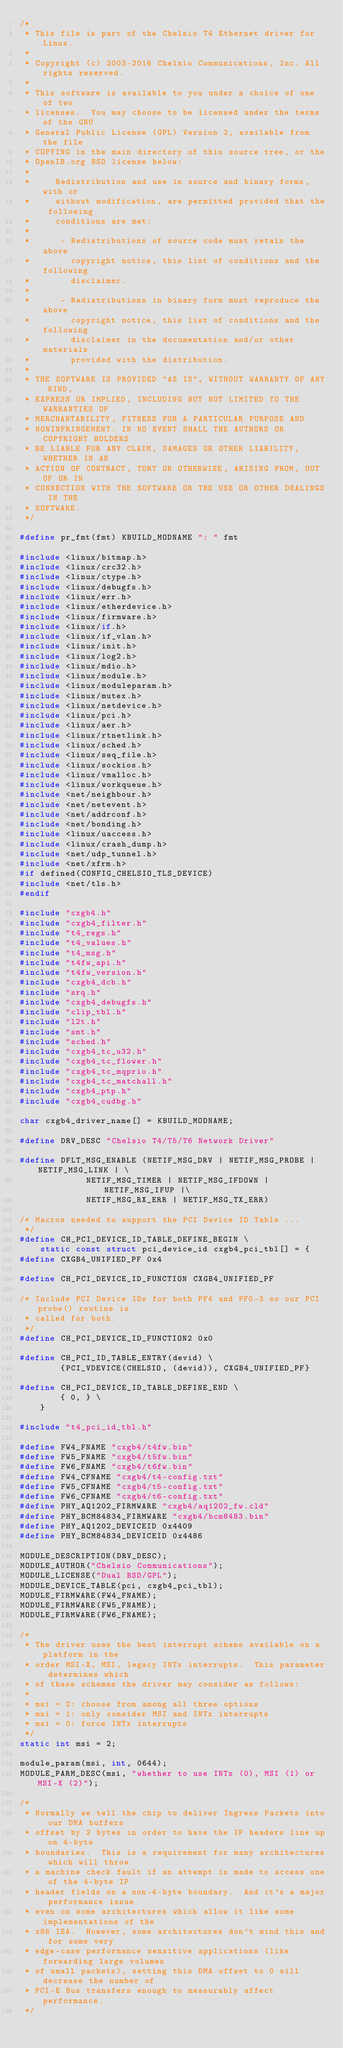Convert code to text. <code><loc_0><loc_0><loc_500><loc_500><_C_>/*
 * This file is part of the Chelsio T4 Ethernet driver for Linux.
 *
 * Copyright (c) 2003-2016 Chelsio Communications, Inc. All rights reserved.
 *
 * This software is available to you under a choice of one of two
 * licenses.  You may choose to be licensed under the terms of the GNU
 * General Public License (GPL) Version 2, available from the file
 * COPYING in the main directory of this source tree, or the
 * OpenIB.org BSD license below:
 *
 *     Redistribution and use in source and binary forms, with or
 *     without modification, are permitted provided that the following
 *     conditions are met:
 *
 *      - Redistributions of source code must retain the above
 *        copyright notice, this list of conditions and the following
 *        disclaimer.
 *
 *      - Redistributions in binary form must reproduce the above
 *        copyright notice, this list of conditions and the following
 *        disclaimer in the documentation and/or other materials
 *        provided with the distribution.
 *
 * THE SOFTWARE IS PROVIDED "AS IS", WITHOUT WARRANTY OF ANY KIND,
 * EXPRESS OR IMPLIED, INCLUDING BUT NOT LIMITED TO THE WARRANTIES OF
 * MERCHANTABILITY, FITNESS FOR A PARTICULAR PURPOSE AND
 * NONINFRINGEMENT. IN NO EVENT SHALL THE AUTHORS OR COPYRIGHT HOLDERS
 * BE LIABLE FOR ANY CLAIM, DAMAGES OR OTHER LIABILITY, WHETHER IN AN
 * ACTION OF CONTRACT, TORT OR OTHERWISE, ARISING FROM, OUT OF OR IN
 * CONNECTION WITH THE SOFTWARE OR THE USE OR OTHER DEALINGS IN THE
 * SOFTWARE.
 */

#define pr_fmt(fmt) KBUILD_MODNAME ": " fmt

#include <linux/bitmap.h>
#include <linux/crc32.h>
#include <linux/ctype.h>
#include <linux/debugfs.h>
#include <linux/err.h>
#include <linux/etherdevice.h>
#include <linux/firmware.h>
#include <linux/if.h>
#include <linux/if_vlan.h>
#include <linux/init.h>
#include <linux/log2.h>
#include <linux/mdio.h>
#include <linux/module.h>
#include <linux/moduleparam.h>
#include <linux/mutex.h>
#include <linux/netdevice.h>
#include <linux/pci.h>
#include <linux/aer.h>
#include <linux/rtnetlink.h>
#include <linux/sched.h>
#include <linux/seq_file.h>
#include <linux/sockios.h>
#include <linux/vmalloc.h>
#include <linux/workqueue.h>
#include <net/neighbour.h>
#include <net/netevent.h>
#include <net/addrconf.h>
#include <net/bonding.h>
#include <linux/uaccess.h>
#include <linux/crash_dump.h>
#include <net/udp_tunnel.h>
#include <net/xfrm.h>
#if defined(CONFIG_CHELSIO_TLS_DEVICE)
#include <net/tls.h>
#endif

#include "cxgb4.h"
#include "cxgb4_filter.h"
#include "t4_regs.h"
#include "t4_values.h"
#include "t4_msg.h"
#include "t4fw_api.h"
#include "t4fw_version.h"
#include "cxgb4_dcb.h"
#include "srq.h"
#include "cxgb4_debugfs.h"
#include "clip_tbl.h"
#include "l2t.h"
#include "smt.h"
#include "sched.h"
#include "cxgb4_tc_u32.h"
#include "cxgb4_tc_flower.h"
#include "cxgb4_tc_mqprio.h"
#include "cxgb4_tc_matchall.h"
#include "cxgb4_ptp.h"
#include "cxgb4_cudbg.h"

char cxgb4_driver_name[] = KBUILD_MODNAME;

#define DRV_DESC "Chelsio T4/T5/T6 Network Driver"

#define DFLT_MSG_ENABLE (NETIF_MSG_DRV | NETIF_MSG_PROBE | NETIF_MSG_LINK | \
			 NETIF_MSG_TIMER | NETIF_MSG_IFDOWN | NETIF_MSG_IFUP |\
			 NETIF_MSG_RX_ERR | NETIF_MSG_TX_ERR)

/* Macros needed to support the PCI Device ID Table ...
 */
#define CH_PCI_DEVICE_ID_TABLE_DEFINE_BEGIN \
	static const struct pci_device_id cxgb4_pci_tbl[] = {
#define CXGB4_UNIFIED_PF 0x4

#define CH_PCI_DEVICE_ID_FUNCTION CXGB4_UNIFIED_PF

/* Include PCI Device IDs for both PF4 and PF0-3 so our PCI probe() routine is
 * called for both.
 */
#define CH_PCI_DEVICE_ID_FUNCTION2 0x0

#define CH_PCI_ID_TABLE_ENTRY(devid) \
		{PCI_VDEVICE(CHELSIO, (devid)), CXGB4_UNIFIED_PF}

#define CH_PCI_DEVICE_ID_TABLE_DEFINE_END \
		{ 0, } \
	}

#include "t4_pci_id_tbl.h"

#define FW4_FNAME "cxgb4/t4fw.bin"
#define FW5_FNAME "cxgb4/t5fw.bin"
#define FW6_FNAME "cxgb4/t6fw.bin"
#define FW4_CFNAME "cxgb4/t4-config.txt"
#define FW5_CFNAME "cxgb4/t5-config.txt"
#define FW6_CFNAME "cxgb4/t6-config.txt"
#define PHY_AQ1202_FIRMWARE "cxgb4/aq1202_fw.cld"
#define PHY_BCM84834_FIRMWARE "cxgb4/bcm8483.bin"
#define PHY_AQ1202_DEVICEID 0x4409
#define PHY_BCM84834_DEVICEID 0x4486

MODULE_DESCRIPTION(DRV_DESC);
MODULE_AUTHOR("Chelsio Communications");
MODULE_LICENSE("Dual BSD/GPL");
MODULE_DEVICE_TABLE(pci, cxgb4_pci_tbl);
MODULE_FIRMWARE(FW4_FNAME);
MODULE_FIRMWARE(FW5_FNAME);
MODULE_FIRMWARE(FW6_FNAME);

/*
 * The driver uses the best interrupt scheme available on a platform in the
 * order MSI-X, MSI, legacy INTx interrupts.  This parameter determines which
 * of these schemes the driver may consider as follows:
 *
 * msi = 2: choose from among all three options
 * msi = 1: only consider MSI and INTx interrupts
 * msi = 0: force INTx interrupts
 */
static int msi = 2;

module_param(msi, int, 0644);
MODULE_PARM_DESC(msi, "whether to use INTx (0), MSI (1) or MSI-X (2)");

/*
 * Normally we tell the chip to deliver Ingress Packets into our DMA buffers
 * offset by 2 bytes in order to have the IP headers line up on 4-byte
 * boundaries.  This is a requirement for many architectures which will throw
 * a machine check fault if an attempt is made to access one of the 4-byte IP
 * header fields on a non-4-byte boundary.  And it's a major performance issue
 * even on some architectures which allow it like some implementations of the
 * x86 ISA.  However, some architectures don't mind this and for some very
 * edge-case performance sensitive applications (like forwarding large volumes
 * of small packets), setting this DMA offset to 0 will decrease the number of
 * PCI-E Bus transfers enough to measurably affect performance.
 */</code> 